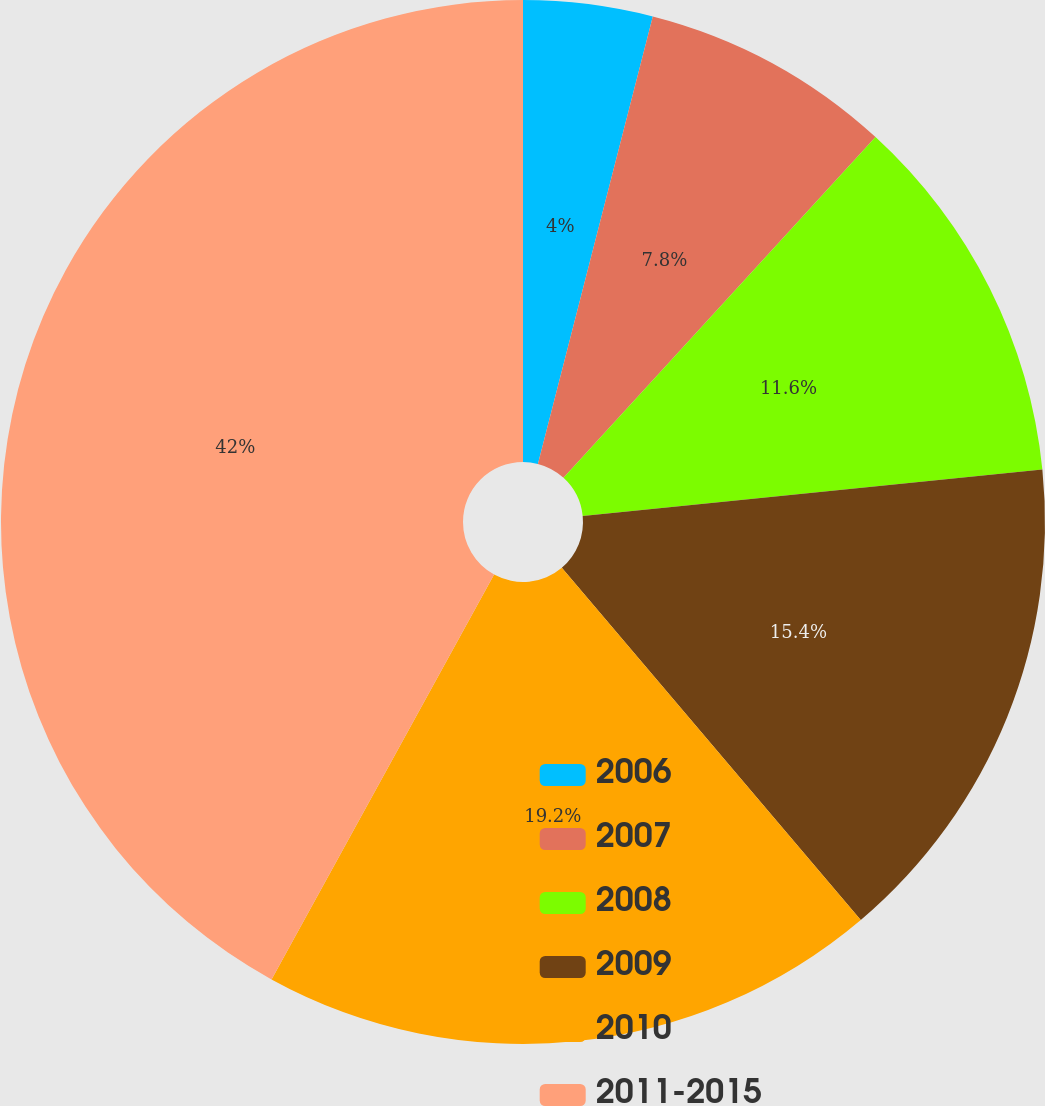<chart> <loc_0><loc_0><loc_500><loc_500><pie_chart><fcel>2006<fcel>2007<fcel>2008<fcel>2009<fcel>2010<fcel>2011-2015<nl><fcel>4.0%<fcel>7.8%<fcel>11.6%<fcel>15.4%<fcel>19.2%<fcel>42.0%<nl></chart> 